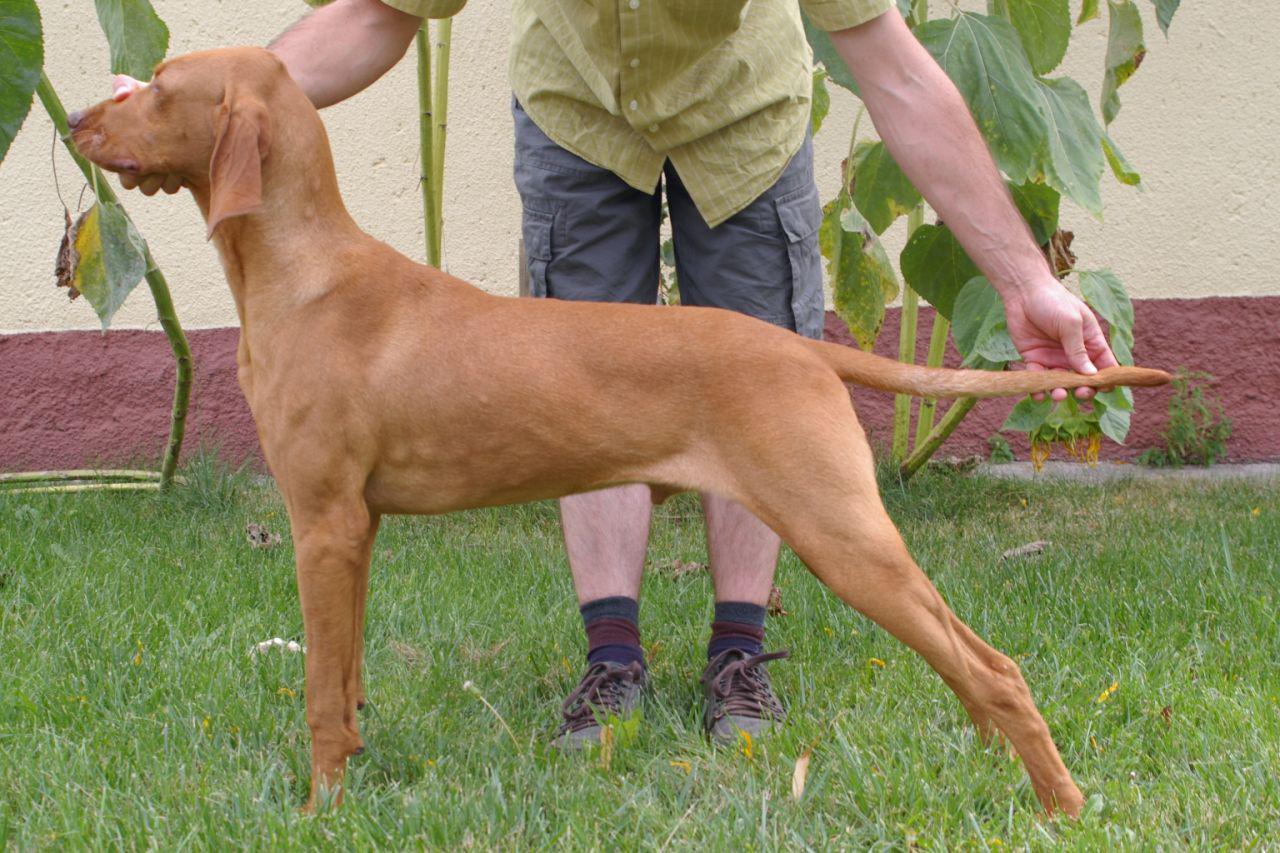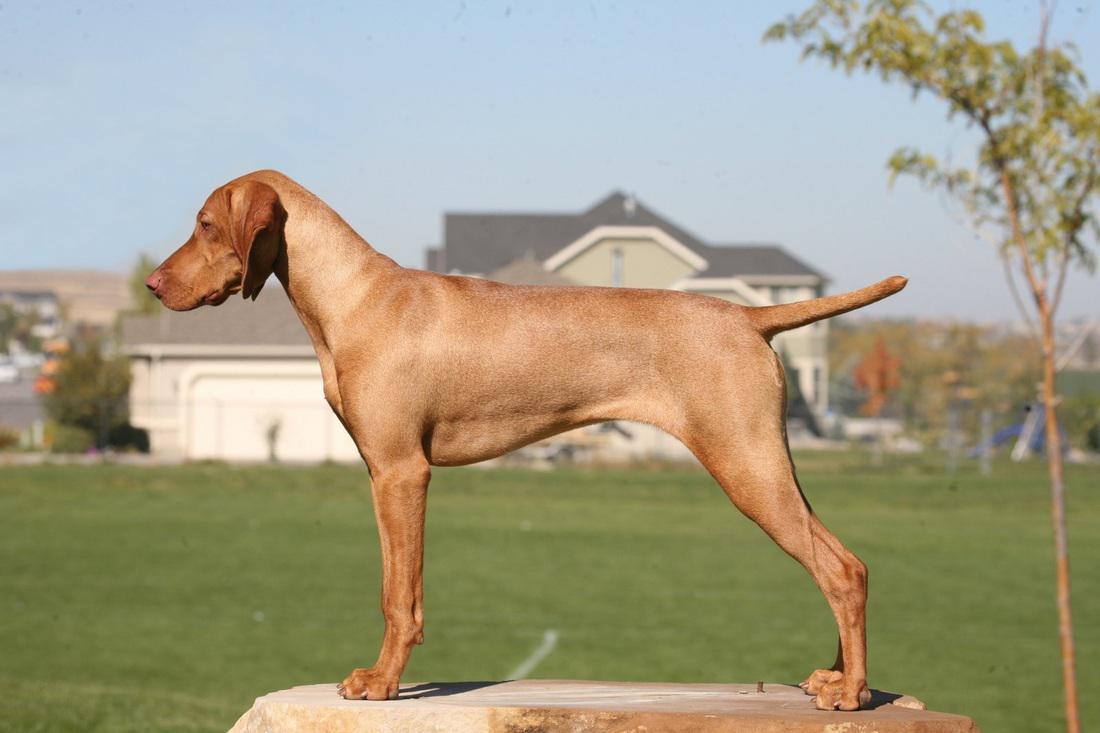The first image is the image on the left, the second image is the image on the right. Analyze the images presented: Is the assertion "At least one image shows one red-orange dog standing with head and body in profile turned leftward, and tail extended." valid? Answer yes or no. Yes. The first image is the image on the left, the second image is the image on the right. Analyze the images presented: Is the assertion "A brown dog stand straight looking to the left while on the grass." valid? Answer yes or no. Yes. 